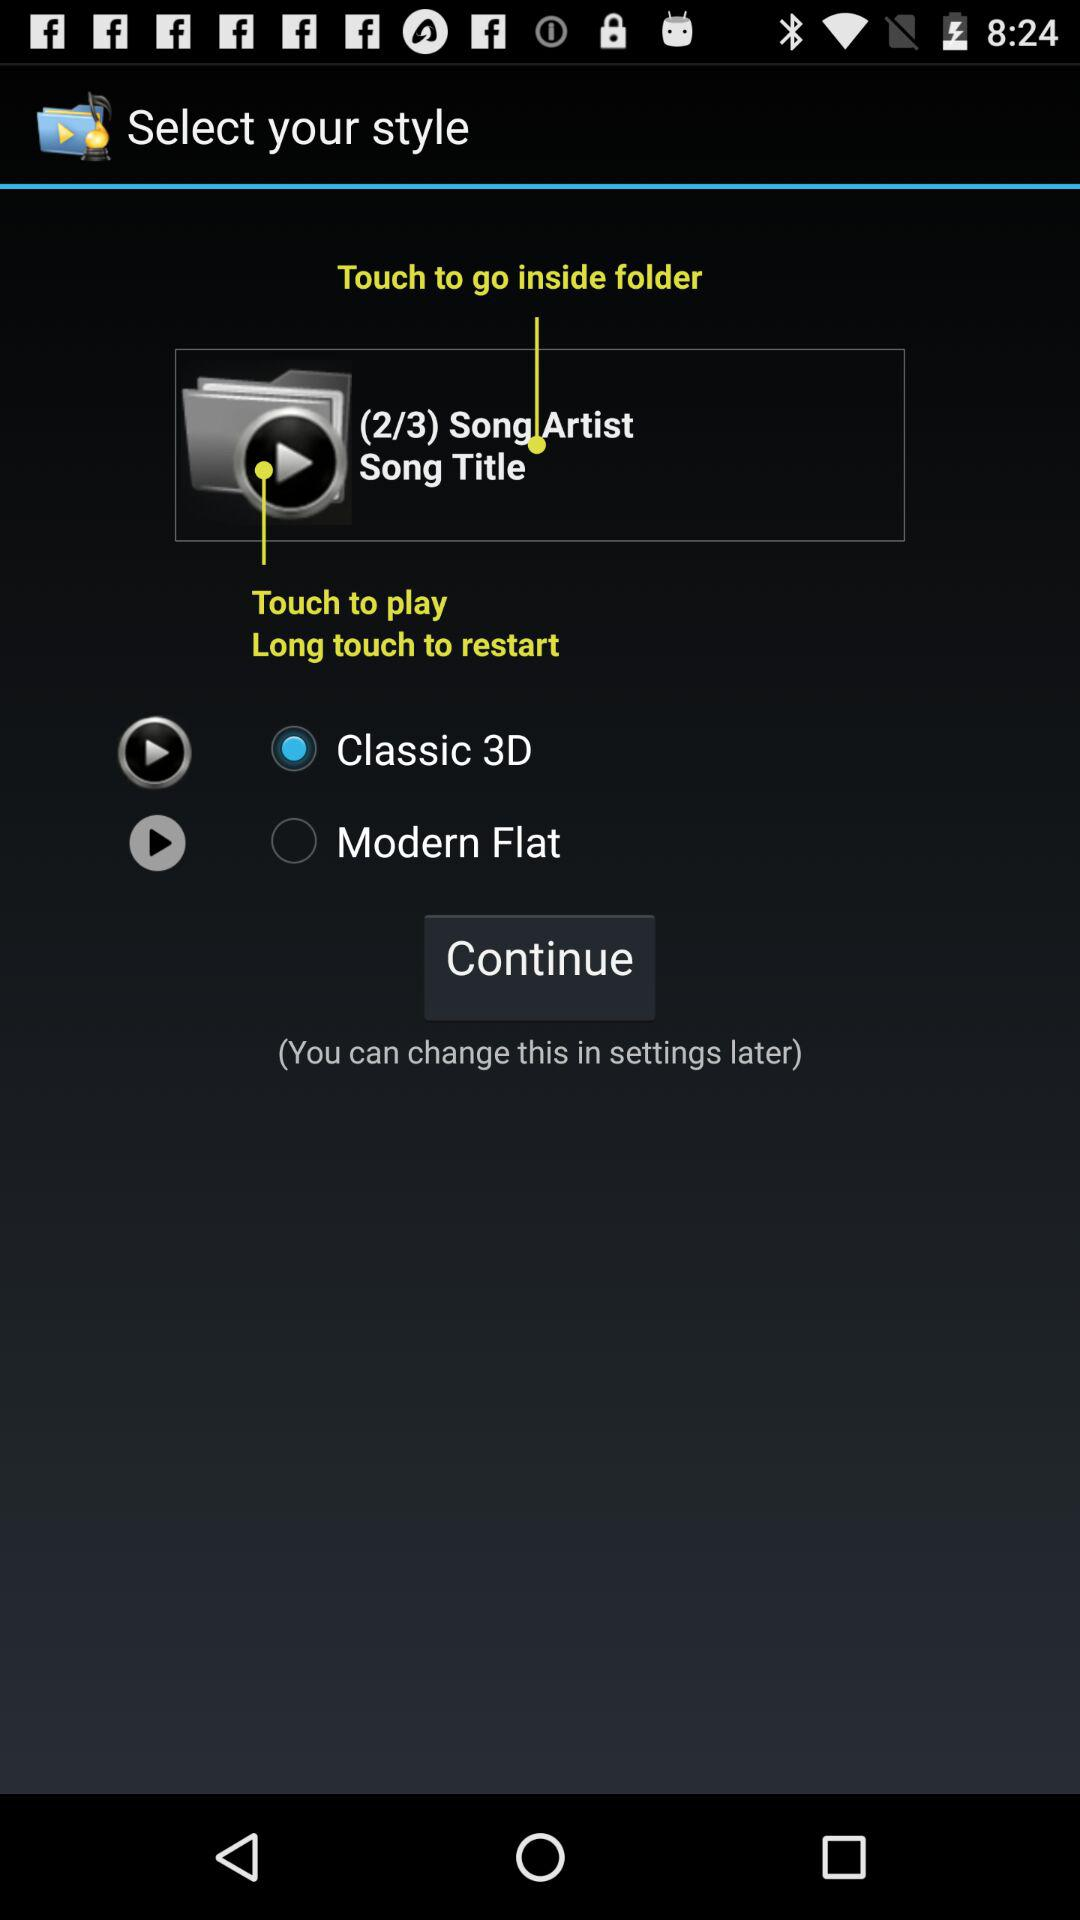In which part of the song are we?
When the provided information is insufficient, respond with <no answer>. <no answer> 